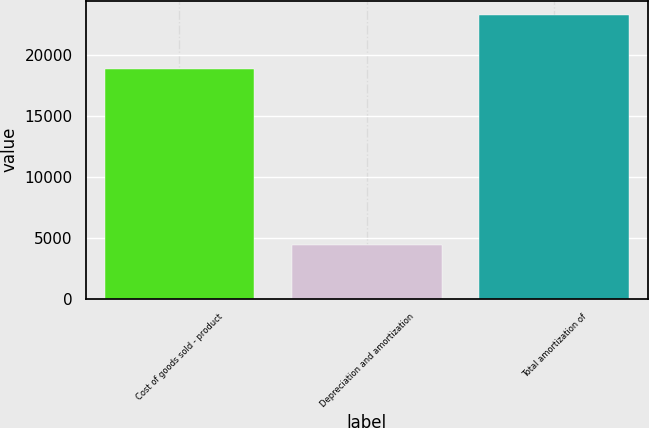Convert chart. <chart><loc_0><loc_0><loc_500><loc_500><bar_chart><fcel>Cost of goods sold - product<fcel>Depreciation and amortization<fcel>Total amortization of<nl><fcel>18870<fcel>4403<fcel>23273<nl></chart> 